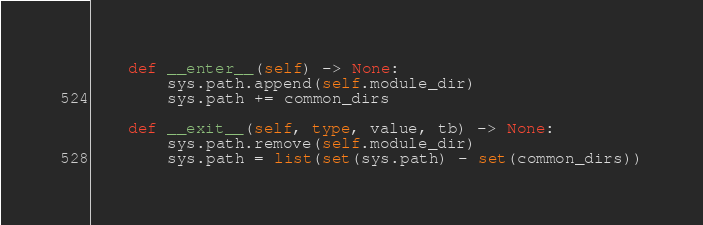Convert code to text. <code><loc_0><loc_0><loc_500><loc_500><_Python_>    def __enter__(self) -> None:
        sys.path.append(self.module_dir)
        sys.path += common_dirs

    def __exit__(self, type, value, tb) -> None:
        sys.path.remove(self.module_dir)
        sys.path = list(set(sys.path) - set(common_dirs))
</code> 